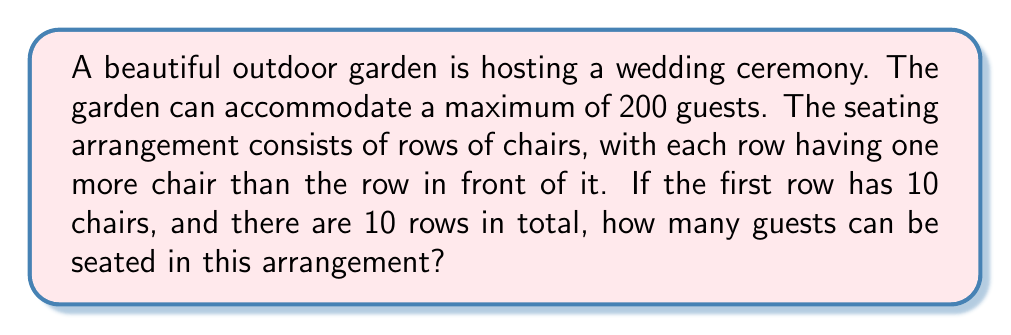Can you answer this question? Let's approach this step-by-step:

1) We are dealing with an arithmetic sequence, where each row has one more chair than the previous row.

2) The first row has 10 chairs, and there are 10 rows in total.

3) Let's define our sequence:
   $a_1 = 10$ (first term)
   $d = 1$ (common difference)
   $n = 10$ (number of terms/rows)

4) We need to find the sum of this arithmetic sequence. The formula for the sum of an arithmetic sequence is:

   $$S_n = \frac{n}{2}(a_1 + a_n)$$

   Where $a_n$ is the last term in the sequence.

5) To find $a_n$, we can use the arithmetic sequence formula:
   
   $$a_n = a_1 + (n-1)d$$
   $$a_{10} = 10 + (10-1)1 = 10 + 9 = 19$$

6) Now we can plug these values into our sum formula:

   $$S_{10} = \frac{10}{2}(10 + 19) = 5(29) = 145$$

Therefore, this seating arrangement can accommodate 145 guests.
Answer: 145 guests 